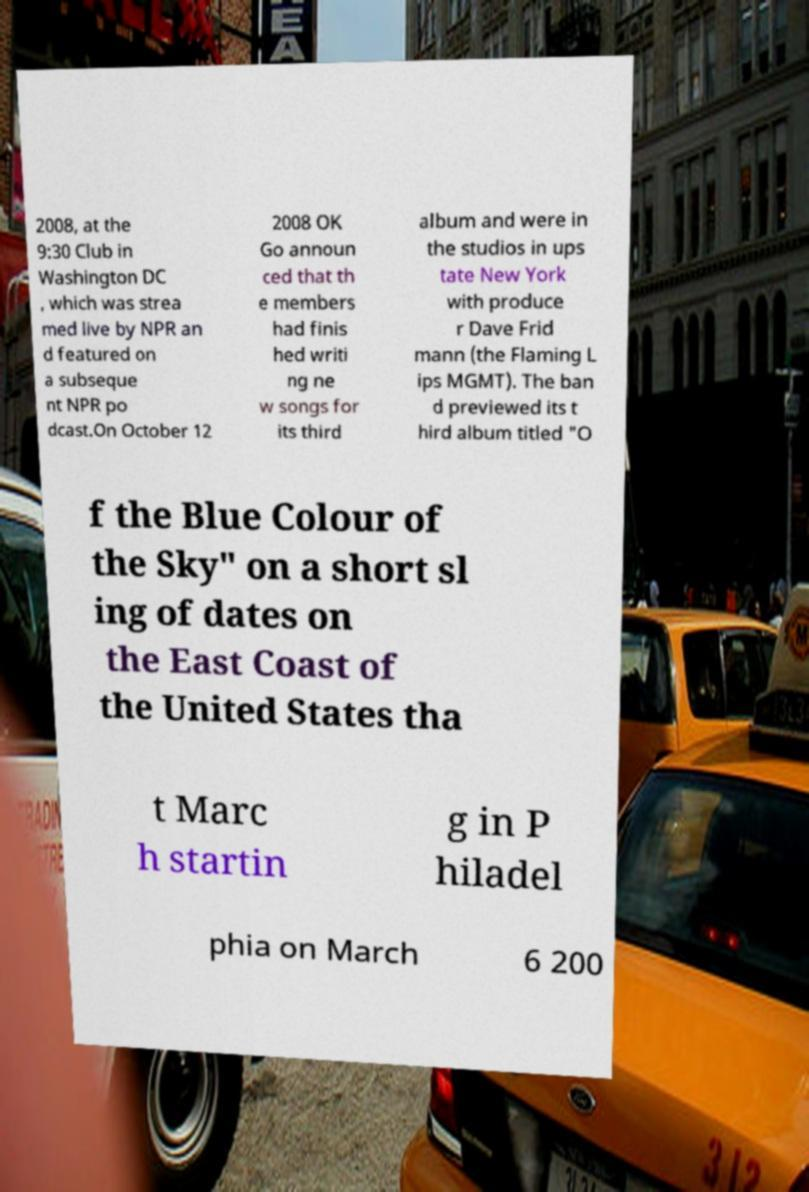Can you accurately transcribe the text from the provided image for me? 2008, at the 9:30 Club in Washington DC , which was strea med live by NPR an d featured on a subseque nt NPR po dcast.On October 12 2008 OK Go announ ced that th e members had finis hed writi ng ne w songs for its third album and were in the studios in ups tate New York with produce r Dave Frid mann (the Flaming L ips MGMT). The ban d previewed its t hird album titled "O f the Blue Colour of the Sky" on a short sl ing of dates on the East Coast of the United States tha t Marc h startin g in P hiladel phia on March 6 200 